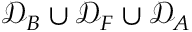Convert formula to latex. <formula><loc_0><loc_0><loc_500><loc_500>\mathcal { D } _ { B } \cup \mathcal { D } _ { F } \cup \mathcal { D } _ { A }</formula> 